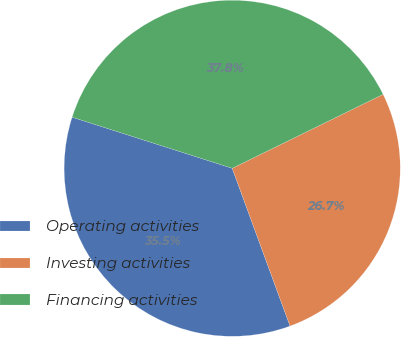<chart> <loc_0><loc_0><loc_500><loc_500><pie_chart><fcel>Operating activities<fcel>Investing activities<fcel>Financing activities<nl><fcel>35.51%<fcel>26.66%<fcel>37.83%<nl></chart> 